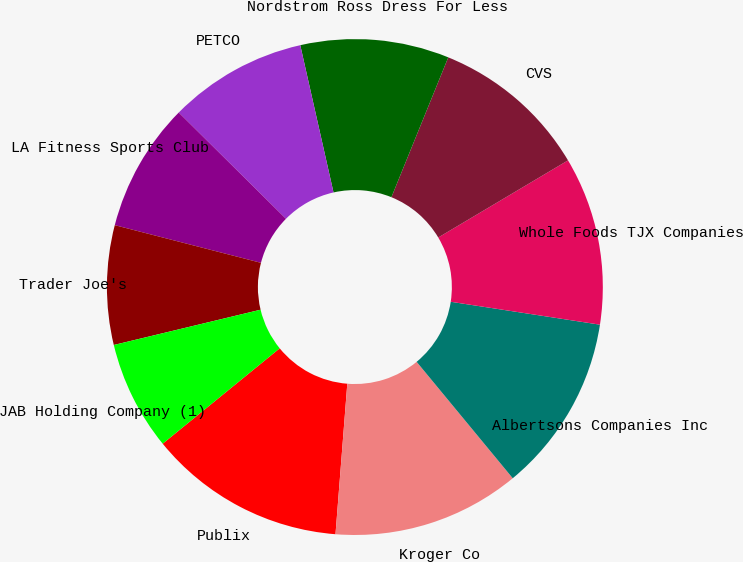<chart> <loc_0><loc_0><loc_500><loc_500><pie_chart><fcel>Publix<fcel>Kroger Co<fcel>Albertsons Companies Inc<fcel>Whole Foods TJX Companies<fcel>CVS<fcel>Nordstrom Ross Dress For Less<fcel>PETCO<fcel>LA Fitness Sports Club<fcel>Trader Joe's<fcel>JAB Holding Company (1)<nl><fcel>12.87%<fcel>12.23%<fcel>11.59%<fcel>10.96%<fcel>10.32%<fcel>9.68%<fcel>9.04%<fcel>8.41%<fcel>7.77%<fcel>7.13%<nl></chart> 